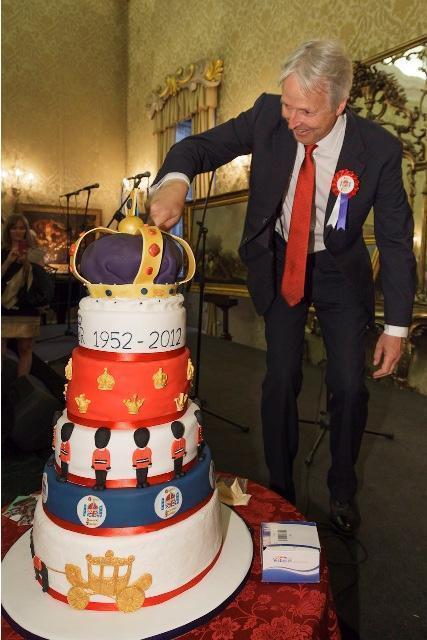How many tiers?
Give a very brief answer. 5. How many dining tables are in the photo?
Give a very brief answer. 1. How many people can you see?
Give a very brief answer. 2. How many cats there?
Give a very brief answer. 0. 